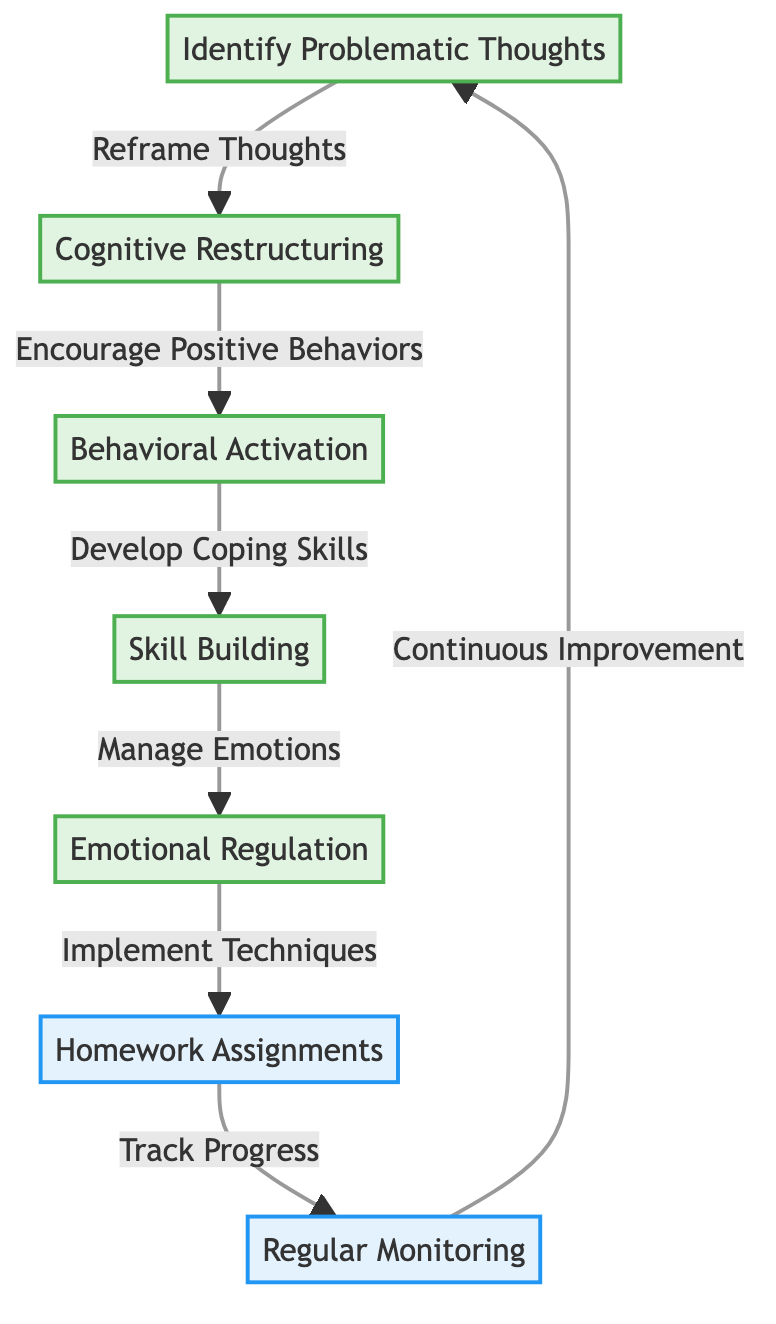What is the first step in the flowchart? The diagram clearly indicates that the first step is to "Identify Problematic Thoughts." This is the starting node in the flowchart, positioned at the top.
Answer: Identify Problematic Thoughts How many action nodes are there in the flowchart? Upon inspecting the diagram, we see that there are two nodes categorized as action: "Homework Assignments" and "Regular Monitoring." Thus, the total count of action nodes is two.
Answer: 2 What does "Cognitive Restructuring" lead to? The flowchart shows that the node "Cognitive Restructuring" directly leads to the next step labeled "Behavioral Activation." This is indicated by the arrow connecting these two nodes.
Answer: Behavioral Activation Which technique connects "Manage Emotions" to "Track Progress"? The flowchart reveals that "Manage Emotions" leads to the action "Track Progress," signified through the arrow linking the two nodes. This is the result of implementing emotional regulation techniques.
Answer: Track Progress What comes after "Emotional Regulation"? According to the diagram, after the "Emotional Regulation" step, the next action is "Homework Assignments," as indicated by the arrow connecting these nodes.
Answer: Homework Assignments How does one move from "Skill Building" to "Manage Emotions"? In the flowchart, the pathway from "Skill Building" to "Manage Emotions" is established by the arrow showing progression from the former to the latter. This indicates that skills developed contribute to managing emotions.
Answer: Manage Emotions What is the relationship between "Homework Assignments" and "Continuous Improvement"? The diagram shows that "Homework Assignments" leads to "Continuous Improvement." This means that completing homework assignments is linked to improving one's progress systematically.
Answer: Continuous Improvement What is the purpose of "Regular Monitoring" in the flowchart? The purpose of "Regular Monitoring," indicated in the diagram, is to assess progress after implementing the techniques, as it follows from "Track Progress" and reconnects back to "Identify Problematic Thoughts." This is part of the continuous feedback cycle.
Answer: Assess progress 